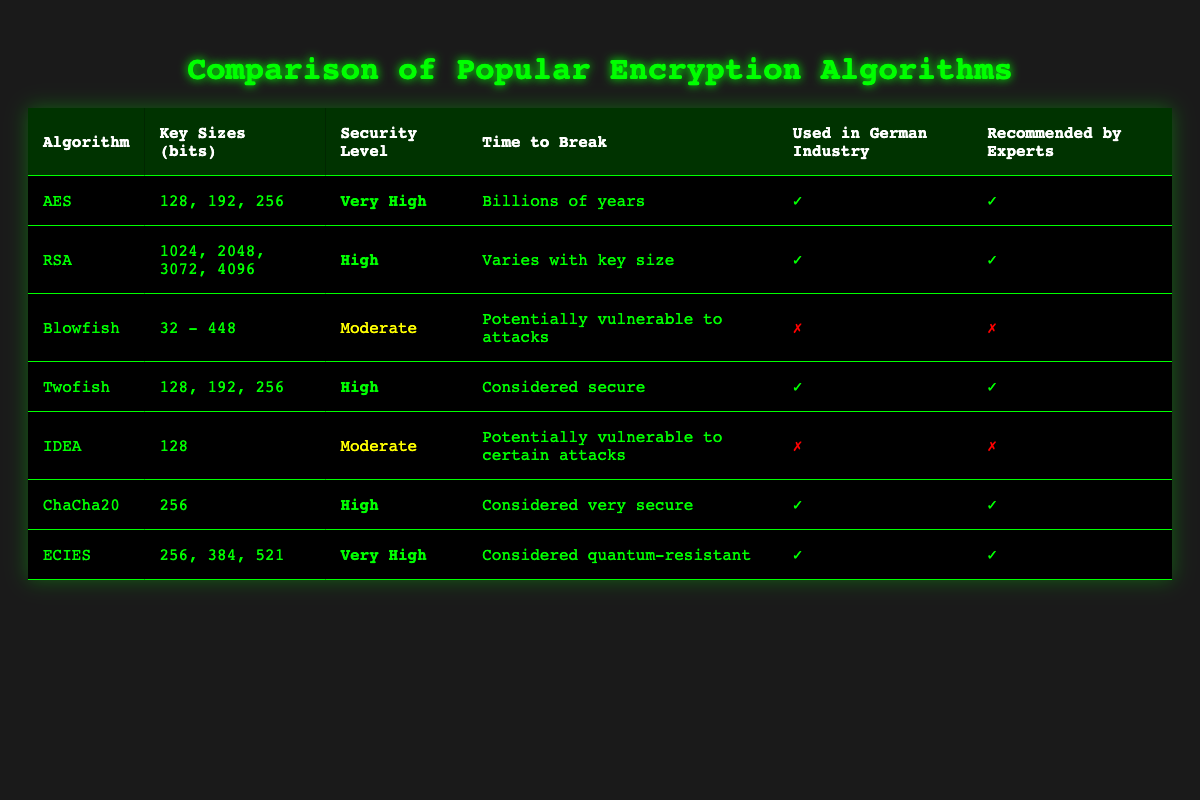What is the highest security level achieved by any algorithm in the table? The table shows two algorithms with the security level "Very High": AES and ECIES. To find the highest level, we only need to look for the security levels listed in the input data.
Answer: Very High Which algorithms use key sizes of 128 bits? The algorithms with a key size of 128 bits listed in the table are AES, Twofish, and IDEA. This information can be retrieved from the 'Key Sizes (bits)' column where 128 is explicitly mentioned.
Answer: AES, Twofish, IDEA Is Blowfish recommended by cybersecurity experts? From the table, we see that Blowfish is marked with a "✗" under the 'Recommended by Experts' column, which indicates that it is not recommended by cybersecurity experts. This is a direct retrieval from the table data.
Answer: No What is the time to break for ChaCha20 compared to AES? The time to break for ChaCha20 is "Considered very secure," while for AES, it is "Billions of years." The comparison shows that AES has a well-defined, extremely long time, while ChaCha20 is described in relative terms.
Answer: AES is more clearly defined, but both are considered very secure How many algorithms are used in the German industry? By observing the 'Used in German Industry' column, we can count the algorithms marked with a "✓", which includes AES, RSA, Twofish, ChaCha20, and ECIES. There are 5 algorithms in total based on this collection.
Answer: 5 What is the average security level of all algorithms listed? The security levels can be assigned numerical values: Very High = 3, High = 2, and Moderate = 1. The count of each is: Very High (2), High (3), Moderate (3). The average is calculated as follows: (3*2 + 2*3 + 1*3) / 8 = (6 + 6 + 3) / 8 = 15 / 8 = 1.875, which corresponds to a security level between High and Moderate.
Answer: Approximately High Is there an algorithm that is both used in the German industry and considered quantum-resistant? The table shows that ECIES is marked with a "✓" for being used in German industry and is also noted as "Considered quantum-resistant." This means there is indeed an algorithm fulfilling both criteria.
Answer: Yes What key size does RSA include that is the highest among this group? From the key sizes listed for RSA in the table, they include 1024, 2048, 3072, and 4096 bits. The highest key size for RSA is 4096 bits, which is straightforward to determine by looking at the key sizes for the RSA row.
Answer: 4096 bits 